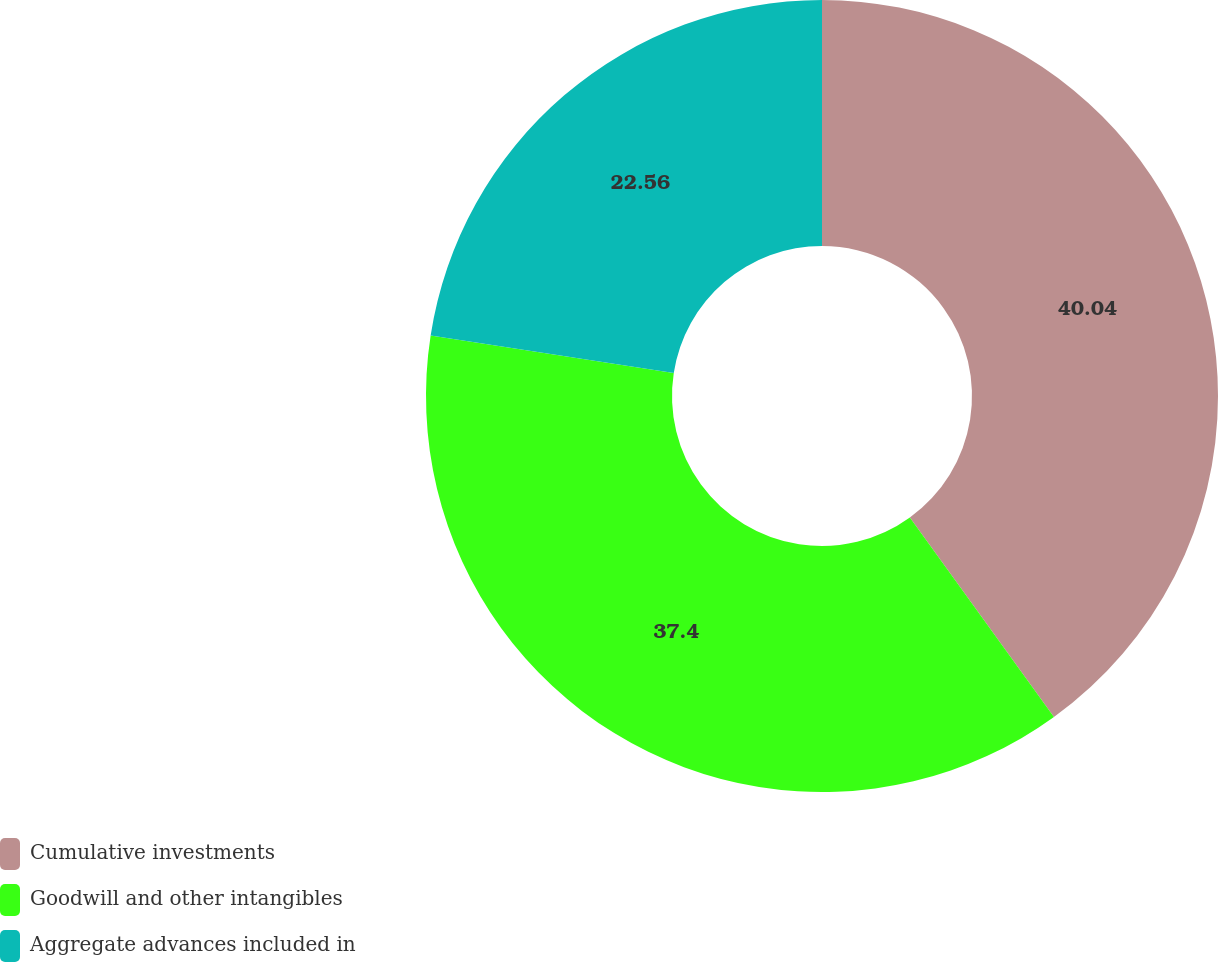Convert chart to OTSL. <chart><loc_0><loc_0><loc_500><loc_500><pie_chart><fcel>Cumulative investments<fcel>Goodwill and other intangibles<fcel>Aggregate advances included in<nl><fcel>40.04%<fcel>37.4%<fcel>22.56%<nl></chart> 